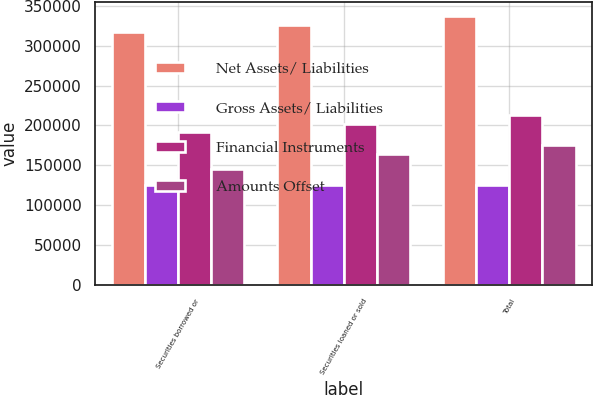<chart> <loc_0><loc_0><loc_500><loc_500><stacked_bar_chart><ecel><fcel>Securities borrowed or<fcel>Securities loaned or sold<fcel>Total<nl><fcel>Net Assets/ Liabilities<fcel>316567<fcel>326007<fcel>337648<nl><fcel>Gross Assets/ Liabilities<fcel>124744<fcel>124744<fcel>124744<nl><fcel>Financial Instruments<fcel>191823<fcel>201263<fcel>212904<nl><fcel>Amounts Offset<fcel>145573<fcel>164306<fcel>175947<nl></chart> 